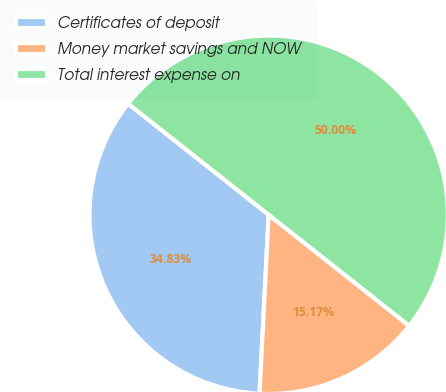Convert chart. <chart><loc_0><loc_0><loc_500><loc_500><pie_chart><fcel>Certificates of deposit<fcel>Money market savings and NOW<fcel>Total interest expense on<nl><fcel>34.83%<fcel>15.17%<fcel>50.0%<nl></chart> 